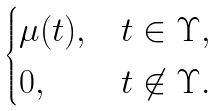Convert formula to latex. <formula><loc_0><loc_0><loc_500><loc_500>\begin{cases} \mu ( t ) , & t \in \Upsilon , \\ 0 , & t \not \in \Upsilon . \end{cases}</formula> 